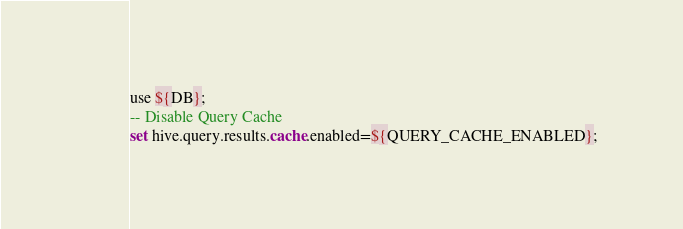Convert code to text. <code><loc_0><loc_0><loc_500><loc_500><_SQL_>use ${DB};
-- Disable Query Cache
set hive.query.results.cache.enabled=${QUERY_CACHE_ENABLED};</code> 